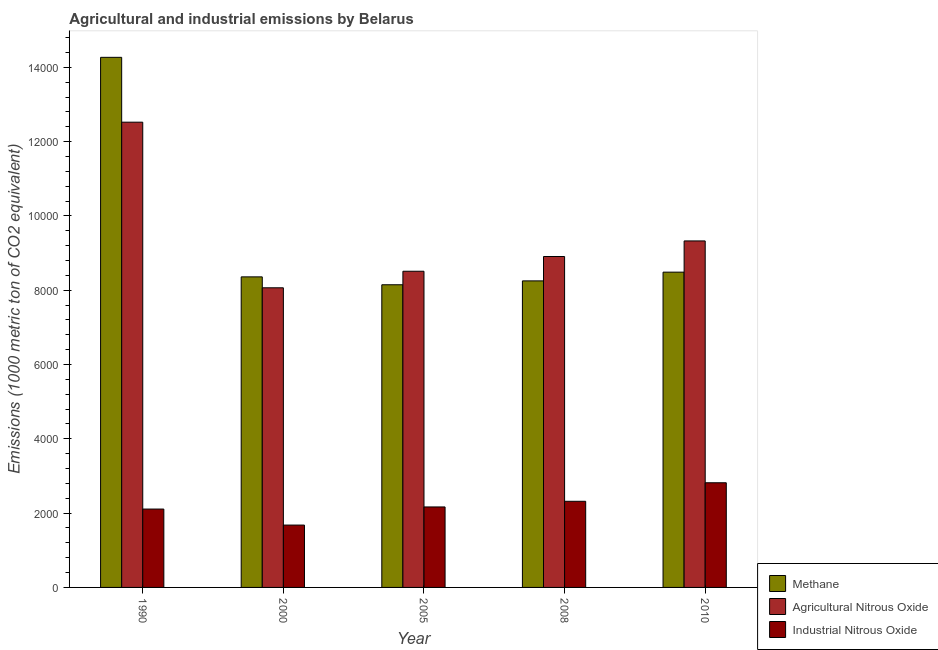How many different coloured bars are there?
Make the answer very short. 3. How many groups of bars are there?
Your answer should be very brief. 5. Are the number of bars on each tick of the X-axis equal?
Give a very brief answer. Yes. How many bars are there on the 5th tick from the left?
Your response must be concise. 3. In how many cases, is the number of bars for a given year not equal to the number of legend labels?
Ensure brevity in your answer.  0. What is the amount of industrial nitrous oxide emissions in 2010?
Your answer should be very brief. 2817.5. Across all years, what is the maximum amount of agricultural nitrous oxide emissions?
Offer a very short reply. 1.25e+04. Across all years, what is the minimum amount of agricultural nitrous oxide emissions?
Your response must be concise. 8066.2. In which year was the amount of agricultural nitrous oxide emissions minimum?
Keep it short and to the point. 2000. What is the total amount of industrial nitrous oxide emissions in the graph?
Ensure brevity in your answer.  1.11e+04. What is the difference between the amount of industrial nitrous oxide emissions in 1990 and that in 2000?
Ensure brevity in your answer.  431. What is the difference between the amount of methane emissions in 1990 and the amount of agricultural nitrous oxide emissions in 2005?
Provide a short and direct response. 6122.6. What is the average amount of industrial nitrous oxide emissions per year?
Your response must be concise. 2218.22. In the year 2000, what is the difference between the amount of industrial nitrous oxide emissions and amount of agricultural nitrous oxide emissions?
Offer a terse response. 0. In how many years, is the amount of agricultural nitrous oxide emissions greater than 2400 metric ton?
Offer a very short reply. 5. What is the ratio of the amount of industrial nitrous oxide emissions in 2000 to that in 2008?
Provide a succinct answer. 0.72. What is the difference between the highest and the second highest amount of agricultural nitrous oxide emissions?
Make the answer very short. 3196.7. What is the difference between the highest and the lowest amount of agricultural nitrous oxide emissions?
Keep it short and to the point. 4458.4. What does the 1st bar from the left in 2005 represents?
Ensure brevity in your answer.  Methane. What does the 1st bar from the right in 1990 represents?
Give a very brief answer. Industrial Nitrous Oxide. Is it the case that in every year, the sum of the amount of methane emissions and amount of agricultural nitrous oxide emissions is greater than the amount of industrial nitrous oxide emissions?
Provide a short and direct response. Yes. Are all the bars in the graph horizontal?
Provide a short and direct response. No. How many years are there in the graph?
Give a very brief answer. 5. What is the difference between two consecutive major ticks on the Y-axis?
Offer a very short reply. 2000. Are the values on the major ticks of Y-axis written in scientific E-notation?
Your answer should be very brief. No. Where does the legend appear in the graph?
Provide a succinct answer. Bottom right. How many legend labels are there?
Make the answer very short. 3. What is the title of the graph?
Your response must be concise. Agricultural and industrial emissions by Belarus. What is the label or title of the X-axis?
Keep it short and to the point. Year. What is the label or title of the Y-axis?
Your answer should be very brief. Emissions (1000 metric ton of CO2 equivalent). What is the Emissions (1000 metric ton of CO2 equivalent) of Methane in 1990?
Keep it short and to the point. 1.43e+04. What is the Emissions (1000 metric ton of CO2 equivalent) of Agricultural Nitrous Oxide in 1990?
Offer a terse response. 1.25e+04. What is the Emissions (1000 metric ton of CO2 equivalent) in Industrial Nitrous Oxide in 1990?
Your answer should be very brief. 2109.6. What is the Emissions (1000 metric ton of CO2 equivalent) of Methane in 2000?
Offer a very short reply. 8360.4. What is the Emissions (1000 metric ton of CO2 equivalent) of Agricultural Nitrous Oxide in 2000?
Your response must be concise. 8066.2. What is the Emissions (1000 metric ton of CO2 equivalent) in Industrial Nitrous Oxide in 2000?
Your response must be concise. 1678.6. What is the Emissions (1000 metric ton of CO2 equivalent) of Methane in 2005?
Your response must be concise. 8147.7. What is the Emissions (1000 metric ton of CO2 equivalent) in Agricultural Nitrous Oxide in 2005?
Keep it short and to the point. 8511.9. What is the Emissions (1000 metric ton of CO2 equivalent) in Industrial Nitrous Oxide in 2005?
Your answer should be compact. 2166.7. What is the Emissions (1000 metric ton of CO2 equivalent) in Methane in 2008?
Offer a very short reply. 8252. What is the Emissions (1000 metric ton of CO2 equivalent) of Agricultural Nitrous Oxide in 2008?
Offer a terse response. 8908.4. What is the Emissions (1000 metric ton of CO2 equivalent) in Industrial Nitrous Oxide in 2008?
Ensure brevity in your answer.  2318.7. What is the Emissions (1000 metric ton of CO2 equivalent) in Methane in 2010?
Your response must be concise. 8487.5. What is the Emissions (1000 metric ton of CO2 equivalent) of Agricultural Nitrous Oxide in 2010?
Your response must be concise. 9327.9. What is the Emissions (1000 metric ton of CO2 equivalent) of Industrial Nitrous Oxide in 2010?
Provide a succinct answer. 2817.5. Across all years, what is the maximum Emissions (1000 metric ton of CO2 equivalent) of Methane?
Offer a very short reply. 1.43e+04. Across all years, what is the maximum Emissions (1000 metric ton of CO2 equivalent) of Agricultural Nitrous Oxide?
Keep it short and to the point. 1.25e+04. Across all years, what is the maximum Emissions (1000 metric ton of CO2 equivalent) in Industrial Nitrous Oxide?
Ensure brevity in your answer.  2817.5. Across all years, what is the minimum Emissions (1000 metric ton of CO2 equivalent) of Methane?
Offer a very short reply. 8147.7. Across all years, what is the minimum Emissions (1000 metric ton of CO2 equivalent) of Agricultural Nitrous Oxide?
Provide a succinct answer. 8066.2. Across all years, what is the minimum Emissions (1000 metric ton of CO2 equivalent) of Industrial Nitrous Oxide?
Give a very brief answer. 1678.6. What is the total Emissions (1000 metric ton of CO2 equivalent) in Methane in the graph?
Provide a succinct answer. 4.75e+04. What is the total Emissions (1000 metric ton of CO2 equivalent) of Agricultural Nitrous Oxide in the graph?
Provide a short and direct response. 4.73e+04. What is the total Emissions (1000 metric ton of CO2 equivalent) of Industrial Nitrous Oxide in the graph?
Give a very brief answer. 1.11e+04. What is the difference between the Emissions (1000 metric ton of CO2 equivalent) of Methane in 1990 and that in 2000?
Provide a short and direct response. 5909.9. What is the difference between the Emissions (1000 metric ton of CO2 equivalent) in Agricultural Nitrous Oxide in 1990 and that in 2000?
Your answer should be very brief. 4458.4. What is the difference between the Emissions (1000 metric ton of CO2 equivalent) in Industrial Nitrous Oxide in 1990 and that in 2000?
Your answer should be very brief. 431. What is the difference between the Emissions (1000 metric ton of CO2 equivalent) of Methane in 1990 and that in 2005?
Keep it short and to the point. 6122.6. What is the difference between the Emissions (1000 metric ton of CO2 equivalent) in Agricultural Nitrous Oxide in 1990 and that in 2005?
Give a very brief answer. 4012.7. What is the difference between the Emissions (1000 metric ton of CO2 equivalent) in Industrial Nitrous Oxide in 1990 and that in 2005?
Your response must be concise. -57.1. What is the difference between the Emissions (1000 metric ton of CO2 equivalent) of Methane in 1990 and that in 2008?
Provide a succinct answer. 6018.3. What is the difference between the Emissions (1000 metric ton of CO2 equivalent) of Agricultural Nitrous Oxide in 1990 and that in 2008?
Make the answer very short. 3616.2. What is the difference between the Emissions (1000 metric ton of CO2 equivalent) of Industrial Nitrous Oxide in 1990 and that in 2008?
Offer a terse response. -209.1. What is the difference between the Emissions (1000 metric ton of CO2 equivalent) in Methane in 1990 and that in 2010?
Offer a terse response. 5782.8. What is the difference between the Emissions (1000 metric ton of CO2 equivalent) in Agricultural Nitrous Oxide in 1990 and that in 2010?
Provide a succinct answer. 3196.7. What is the difference between the Emissions (1000 metric ton of CO2 equivalent) of Industrial Nitrous Oxide in 1990 and that in 2010?
Give a very brief answer. -707.9. What is the difference between the Emissions (1000 metric ton of CO2 equivalent) of Methane in 2000 and that in 2005?
Ensure brevity in your answer.  212.7. What is the difference between the Emissions (1000 metric ton of CO2 equivalent) in Agricultural Nitrous Oxide in 2000 and that in 2005?
Give a very brief answer. -445.7. What is the difference between the Emissions (1000 metric ton of CO2 equivalent) of Industrial Nitrous Oxide in 2000 and that in 2005?
Provide a short and direct response. -488.1. What is the difference between the Emissions (1000 metric ton of CO2 equivalent) of Methane in 2000 and that in 2008?
Give a very brief answer. 108.4. What is the difference between the Emissions (1000 metric ton of CO2 equivalent) in Agricultural Nitrous Oxide in 2000 and that in 2008?
Offer a terse response. -842.2. What is the difference between the Emissions (1000 metric ton of CO2 equivalent) of Industrial Nitrous Oxide in 2000 and that in 2008?
Provide a short and direct response. -640.1. What is the difference between the Emissions (1000 metric ton of CO2 equivalent) of Methane in 2000 and that in 2010?
Keep it short and to the point. -127.1. What is the difference between the Emissions (1000 metric ton of CO2 equivalent) in Agricultural Nitrous Oxide in 2000 and that in 2010?
Your answer should be compact. -1261.7. What is the difference between the Emissions (1000 metric ton of CO2 equivalent) in Industrial Nitrous Oxide in 2000 and that in 2010?
Keep it short and to the point. -1138.9. What is the difference between the Emissions (1000 metric ton of CO2 equivalent) of Methane in 2005 and that in 2008?
Offer a very short reply. -104.3. What is the difference between the Emissions (1000 metric ton of CO2 equivalent) of Agricultural Nitrous Oxide in 2005 and that in 2008?
Make the answer very short. -396.5. What is the difference between the Emissions (1000 metric ton of CO2 equivalent) in Industrial Nitrous Oxide in 2005 and that in 2008?
Keep it short and to the point. -152. What is the difference between the Emissions (1000 metric ton of CO2 equivalent) in Methane in 2005 and that in 2010?
Your answer should be very brief. -339.8. What is the difference between the Emissions (1000 metric ton of CO2 equivalent) of Agricultural Nitrous Oxide in 2005 and that in 2010?
Keep it short and to the point. -816. What is the difference between the Emissions (1000 metric ton of CO2 equivalent) in Industrial Nitrous Oxide in 2005 and that in 2010?
Give a very brief answer. -650.8. What is the difference between the Emissions (1000 metric ton of CO2 equivalent) of Methane in 2008 and that in 2010?
Provide a succinct answer. -235.5. What is the difference between the Emissions (1000 metric ton of CO2 equivalent) of Agricultural Nitrous Oxide in 2008 and that in 2010?
Offer a terse response. -419.5. What is the difference between the Emissions (1000 metric ton of CO2 equivalent) of Industrial Nitrous Oxide in 2008 and that in 2010?
Your answer should be compact. -498.8. What is the difference between the Emissions (1000 metric ton of CO2 equivalent) of Methane in 1990 and the Emissions (1000 metric ton of CO2 equivalent) of Agricultural Nitrous Oxide in 2000?
Provide a short and direct response. 6204.1. What is the difference between the Emissions (1000 metric ton of CO2 equivalent) of Methane in 1990 and the Emissions (1000 metric ton of CO2 equivalent) of Industrial Nitrous Oxide in 2000?
Keep it short and to the point. 1.26e+04. What is the difference between the Emissions (1000 metric ton of CO2 equivalent) in Agricultural Nitrous Oxide in 1990 and the Emissions (1000 metric ton of CO2 equivalent) in Industrial Nitrous Oxide in 2000?
Your answer should be compact. 1.08e+04. What is the difference between the Emissions (1000 metric ton of CO2 equivalent) of Methane in 1990 and the Emissions (1000 metric ton of CO2 equivalent) of Agricultural Nitrous Oxide in 2005?
Offer a very short reply. 5758.4. What is the difference between the Emissions (1000 metric ton of CO2 equivalent) of Methane in 1990 and the Emissions (1000 metric ton of CO2 equivalent) of Industrial Nitrous Oxide in 2005?
Provide a succinct answer. 1.21e+04. What is the difference between the Emissions (1000 metric ton of CO2 equivalent) in Agricultural Nitrous Oxide in 1990 and the Emissions (1000 metric ton of CO2 equivalent) in Industrial Nitrous Oxide in 2005?
Your response must be concise. 1.04e+04. What is the difference between the Emissions (1000 metric ton of CO2 equivalent) in Methane in 1990 and the Emissions (1000 metric ton of CO2 equivalent) in Agricultural Nitrous Oxide in 2008?
Your answer should be very brief. 5361.9. What is the difference between the Emissions (1000 metric ton of CO2 equivalent) of Methane in 1990 and the Emissions (1000 metric ton of CO2 equivalent) of Industrial Nitrous Oxide in 2008?
Your response must be concise. 1.20e+04. What is the difference between the Emissions (1000 metric ton of CO2 equivalent) in Agricultural Nitrous Oxide in 1990 and the Emissions (1000 metric ton of CO2 equivalent) in Industrial Nitrous Oxide in 2008?
Your answer should be compact. 1.02e+04. What is the difference between the Emissions (1000 metric ton of CO2 equivalent) of Methane in 1990 and the Emissions (1000 metric ton of CO2 equivalent) of Agricultural Nitrous Oxide in 2010?
Give a very brief answer. 4942.4. What is the difference between the Emissions (1000 metric ton of CO2 equivalent) of Methane in 1990 and the Emissions (1000 metric ton of CO2 equivalent) of Industrial Nitrous Oxide in 2010?
Offer a very short reply. 1.15e+04. What is the difference between the Emissions (1000 metric ton of CO2 equivalent) of Agricultural Nitrous Oxide in 1990 and the Emissions (1000 metric ton of CO2 equivalent) of Industrial Nitrous Oxide in 2010?
Keep it short and to the point. 9707.1. What is the difference between the Emissions (1000 metric ton of CO2 equivalent) of Methane in 2000 and the Emissions (1000 metric ton of CO2 equivalent) of Agricultural Nitrous Oxide in 2005?
Keep it short and to the point. -151.5. What is the difference between the Emissions (1000 metric ton of CO2 equivalent) of Methane in 2000 and the Emissions (1000 metric ton of CO2 equivalent) of Industrial Nitrous Oxide in 2005?
Give a very brief answer. 6193.7. What is the difference between the Emissions (1000 metric ton of CO2 equivalent) of Agricultural Nitrous Oxide in 2000 and the Emissions (1000 metric ton of CO2 equivalent) of Industrial Nitrous Oxide in 2005?
Make the answer very short. 5899.5. What is the difference between the Emissions (1000 metric ton of CO2 equivalent) in Methane in 2000 and the Emissions (1000 metric ton of CO2 equivalent) in Agricultural Nitrous Oxide in 2008?
Your response must be concise. -548. What is the difference between the Emissions (1000 metric ton of CO2 equivalent) in Methane in 2000 and the Emissions (1000 metric ton of CO2 equivalent) in Industrial Nitrous Oxide in 2008?
Ensure brevity in your answer.  6041.7. What is the difference between the Emissions (1000 metric ton of CO2 equivalent) of Agricultural Nitrous Oxide in 2000 and the Emissions (1000 metric ton of CO2 equivalent) of Industrial Nitrous Oxide in 2008?
Offer a terse response. 5747.5. What is the difference between the Emissions (1000 metric ton of CO2 equivalent) of Methane in 2000 and the Emissions (1000 metric ton of CO2 equivalent) of Agricultural Nitrous Oxide in 2010?
Your response must be concise. -967.5. What is the difference between the Emissions (1000 metric ton of CO2 equivalent) of Methane in 2000 and the Emissions (1000 metric ton of CO2 equivalent) of Industrial Nitrous Oxide in 2010?
Make the answer very short. 5542.9. What is the difference between the Emissions (1000 metric ton of CO2 equivalent) in Agricultural Nitrous Oxide in 2000 and the Emissions (1000 metric ton of CO2 equivalent) in Industrial Nitrous Oxide in 2010?
Your answer should be compact. 5248.7. What is the difference between the Emissions (1000 metric ton of CO2 equivalent) in Methane in 2005 and the Emissions (1000 metric ton of CO2 equivalent) in Agricultural Nitrous Oxide in 2008?
Give a very brief answer. -760.7. What is the difference between the Emissions (1000 metric ton of CO2 equivalent) in Methane in 2005 and the Emissions (1000 metric ton of CO2 equivalent) in Industrial Nitrous Oxide in 2008?
Your answer should be very brief. 5829. What is the difference between the Emissions (1000 metric ton of CO2 equivalent) in Agricultural Nitrous Oxide in 2005 and the Emissions (1000 metric ton of CO2 equivalent) in Industrial Nitrous Oxide in 2008?
Give a very brief answer. 6193.2. What is the difference between the Emissions (1000 metric ton of CO2 equivalent) in Methane in 2005 and the Emissions (1000 metric ton of CO2 equivalent) in Agricultural Nitrous Oxide in 2010?
Your response must be concise. -1180.2. What is the difference between the Emissions (1000 metric ton of CO2 equivalent) in Methane in 2005 and the Emissions (1000 metric ton of CO2 equivalent) in Industrial Nitrous Oxide in 2010?
Your answer should be very brief. 5330.2. What is the difference between the Emissions (1000 metric ton of CO2 equivalent) of Agricultural Nitrous Oxide in 2005 and the Emissions (1000 metric ton of CO2 equivalent) of Industrial Nitrous Oxide in 2010?
Offer a very short reply. 5694.4. What is the difference between the Emissions (1000 metric ton of CO2 equivalent) in Methane in 2008 and the Emissions (1000 metric ton of CO2 equivalent) in Agricultural Nitrous Oxide in 2010?
Offer a very short reply. -1075.9. What is the difference between the Emissions (1000 metric ton of CO2 equivalent) in Methane in 2008 and the Emissions (1000 metric ton of CO2 equivalent) in Industrial Nitrous Oxide in 2010?
Your answer should be very brief. 5434.5. What is the difference between the Emissions (1000 metric ton of CO2 equivalent) of Agricultural Nitrous Oxide in 2008 and the Emissions (1000 metric ton of CO2 equivalent) of Industrial Nitrous Oxide in 2010?
Give a very brief answer. 6090.9. What is the average Emissions (1000 metric ton of CO2 equivalent) of Methane per year?
Provide a short and direct response. 9503.58. What is the average Emissions (1000 metric ton of CO2 equivalent) in Agricultural Nitrous Oxide per year?
Offer a terse response. 9467.8. What is the average Emissions (1000 metric ton of CO2 equivalent) of Industrial Nitrous Oxide per year?
Offer a very short reply. 2218.22. In the year 1990, what is the difference between the Emissions (1000 metric ton of CO2 equivalent) of Methane and Emissions (1000 metric ton of CO2 equivalent) of Agricultural Nitrous Oxide?
Offer a very short reply. 1745.7. In the year 1990, what is the difference between the Emissions (1000 metric ton of CO2 equivalent) in Methane and Emissions (1000 metric ton of CO2 equivalent) in Industrial Nitrous Oxide?
Keep it short and to the point. 1.22e+04. In the year 1990, what is the difference between the Emissions (1000 metric ton of CO2 equivalent) in Agricultural Nitrous Oxide and Emissions (1000 metric ton of CO2 equivalent) in Industrial Nitrous Oxide?
Ensure brevity in your answer.  1.04e+04. In the year 2000, what is the difference between the Emissions (1000 metric ton of CO2 equivalent) in Methane and Emissions (1000 metric ton of CO2 equivalent) in Agricultural Nitrous Oxide?
Make the answer very short. 294.2. In the year 2000, what is the difference between the Emissions (1000 metric ton of CO2 equivalent) in Methane and Emissions (1000 metric ton of CO2 equivalent) in Industrial Nitrous Oxide?
Ensure brevity in your answer.  6681.8. In the year 2000, what is the difference between the Emissions (1000 metric ton of CO2 equivalent) of Agricultural Nitrous Oxide and Emissions (1000 metric ton of CO2 equivalent) of Industrial Nitrous Oxide?
Your answer should be very brief. 6387.6. In the year 2005, what is the difference between the Emissions (1000 metric ton of CO2 equivalent) of Methane and Emissions (1000 metric ton of CO2 equivalent) of Agricultural Nitrous Oxide?
Your answer should be compact. -364.2. In the year 2005, what is the difference between the Emissions (1000 metric ton of CO2 equivalent) of Methane and Emissions (1000 metric ton of CO2 equivalent) of Industrial Nitrous Oxide?
Your response must be concise. 5981. In the year 2005, what is the difference between the Emissions (1000 metric ton of CO2 equivalent) of Agricultural Nitrous Oxide and Emissions (1000 metric ton of CO2 equivalent) of Industrial Nitrous Oxide?
Offer a terse response. 6345.2. In the year 2008, what is the difference between the Emissions (1000 metric ton of CO2 equivalent) of Methane and Emissions (1000 metric ton of CO2 equivalent) of Agricultural Nitrous Oxide?
Provide a succinct answer. -656.4. In the year 2008, what is the difference between the Emissions (1000 metric ton of CO2 equivalent) of Methane and Emissions (1000 metric ton of CO2 equivalent) of Industrial Nitrous Oxide?
Ensure brevity in your answer.  5933.3. In the year 2008, what is the difference between the Emissions (1000 metric ton of CO2 equivalent) of Agricultural Nitrous Oxide and Emissions (1000 metric ton of CO2 equivalent) of Industrial Nitrous Oxide?
Provide a succinct answer. 6589.7. In the year 2010, what is the difference between the Emissions (1000 metric ton of CO2 equivalent) of Methane and Emissions (1000 metric ton of CO2 equivalent) of Agricultural Nitrous Oxide?
Provide a short and direct response. -840.4. In the year 2010, what is the difference between the Emissions (1000 metric ton of CO2 equivalent) of Methane and Emissions (1000 metric ton of CO2 equivalent) of Industrial Nitrous Oxide?
Offer a very short reply. 5670. In the year 2010, what is the difference between the Emissions (1000 metric ton of CO2 equivalent) in Agricultural Nitrous Oxide and Emissions (1000 metric ton of CO2 equivalent) in Industrial Nitrous Oxide?
Give a very brief answer. 6510.4. What is the ratio of the Emissions (1000 metric ton of CO2 equivalent) in Methane in 1990 to that in 2000?
Your response must be concise. 1.71. What is the ratio of the Emissions (1000 metric ton of CO2 equivalent) in Agricultural Nitrous Oxide in 1990 to that in 2000?
Make the answer very short. 1.55. What is the ratio of the Emissions (1000 metric ton of CO2 equivalent) of Industrial Nitrous Oxide in 1990 to that in 2000?
Give a very brief answer. 1.26. What is the ratio of the Emissions (1000 metric ton of CO2 equivalent) in Methane in 1990 to that in 2005?
Give a very brief answer. 1.75. What is the ratio of the Emissions (1000 metric ton of CO2 equivalent) of Agricultural Nitrous Oxide in 1990 to that in 2005?
Your answer should be very brief. 1.47. What is the ratio of the Emissions (1000 metric ton of CO2 equivalent) in Industrial Nitrous Oxide in 1990 to that in 2005?
Provide a short and direct response. 0.97. What is the ratio of the Emissions (1000 metric ton of CO2 equivalent) in Methane in 1990 to that in 2008?
Offer a terse response. 1.73. What is the ratio of the Emissions (1000 metric ton of CO2 equivalent) of Agricultural Nitrous Oxide in 1990 to that in 2008?
Your answer should be compact. 1.41. What is the ratio of the Emissions (1000 metric ton of CO2 equivalent) of Industrial Nitrous Oxide in 1990 to that in 2008?
Ensure brevity in your answer.  0.91. What is the ratio of the Emissions (1000 metric ton of CO2 equivalent) in Methane in 1990 to that in 2010?
Provide a succinct answer. 1.68. What is the ratio of the Emissions (1000 metric ton of CO2 equivalent) in Agricultural Nitrous Oxide in 1990 to that in 2010?
Make the answer very short. 1.34. What is the ratio of the Emissions (1000 metric ton of CO2 equivalent) of Industrial Nitrous Oxide in 1990 to that in 2010?
Offer a very short reply. 0.75. What is the ratio of the Emissions (1000 metric ton of CO2 equivalent) in Methane in 2000 to that in 2005?
Your answer should be compact. 1.03. What is the ratio of the Emissions (1000 metric ton of CO2 equivalent) of Agricultural Nitrous Oxide in 2000 to that in 2005?
Provide a succinct answer. 0.95. What is the ratio of the Emissions (1000 metric ton of CO2 equivalent) of Industrial Nitrous Oxide in 2000 to that in 2005?
Provide a short and direct response. 0.77. What is the ratio of the Emissions (1000 metric ton of CO2 equivalent) in Methane in 2000 to that in 2008?
Your response must be concise. 1.01. What is the ratio of the Emissions (1000 metric ton of CO2 equivalent) in Agricultural Nitrous Oxide in 2000 to that in 2008?
Give a very brief answer. 0.91. What is the ratio of the Emissions (1000 metric ton of CO2 equivalent) of Industrial Nitrous Oxide in 2000 to that in 2008?
Your answer should be very brief. 0.72. What is the ratio of the Emissions (1000 metric ton of CO2 equivalent) of Agricultural Nitrous Oxide in 2000 to that in 2010?
Your answer should be very brief. 0.86. What is the ratio of the Emissions (1000 metric ton of CO2 equivalent) of Industrial Nitrous Oxide in 2000 to that in 2010?
Make the answer very short. 0.6. What is the ratio of the Emissions (1000 metric ton of CO2 equivalent) in Methane in 2005 to that in 2008?
Offer a very short reply. 0.99. What is the ratio of the Emissions (1000 metric ton of CO2 equivalent) of Agricultural Nitrous Oxide in 2005 to that in 2008?
Give a very brief answer. 0.96. What is the ratio of the Emissions (1000 metric ton of CO2 equivalent) of Industrial Nitrous Oxide in 2005 to that in 2008?
Give a very brief answer. 0.93. What is the ratio of the Emissions (1000 metric ton of CO2 equivalent) of Methane in 2005 to that in 2010?
Your answer should be compact. 0.96. What is the ratio of the Emissions (1000 metric ton of CO2 equivalent) of Agricultural Nitrous Oxide in 2005 to that in 2010?
Keep it short and to the point. 0.91. What is the ratio of the Emissions (1000 metric ton of CO2 equivalent) of Industrial Nitrous Oxide in 2005 to that in 2010?
Your answer should be compact. 0.77. What is the ratio of the Emissions (1000 metric ton of CO2 equivalent) in Methane in 2008 to that in 2010?
Ensure brevity in your answer.  0.97. What is the ratio of the Emissions (1000 metric ton of CO2 equivalent) in Agricultural Nitrous Oxide in 2008 to that in 2010?
Keep it short and to the point. 0.95. What is the ratio of the Emissions (1000 metric ton of CO2 equivalent) of Industrial Nitrous Oxide in 2008 to that in 2010?
Your response must be concise. 0.82. What is the difference between the highest and the second highest Emissions (1000 metric ton of CO2 equivalent) of Methane?
Your response must be concise. 5782.8. What is the difference between the highest and the second highest Emissions (1000 metric ton of CO2 equivalent) in Agricultural Nitrous Oxide?
Keep it short and to the point. 3196.7. What is the difference between the highest and the second highest Emissions (1000 metric ton of CO2 equivalent) in Industrial Nitrous Oxide?
Provide a succinct answer. 498.8. What is the difference between the highest and the lowest Emissions (1000 metric ton of CO2 equivalent) of Methane?
Offer a terse response. 6122.6. What is the difference between the highest and the lowest Emissions (1000 metric ton of CO2 equivalent) of Agricultural Nitrous Oxide?
Keep it short and to the point. 4458.4. What is the difference between the highest and the lowest Emissions (1000 metric ton of CO2 equivalent) in Industrial Nitrous Oxide?
Your response must be concise. 1138.9. 